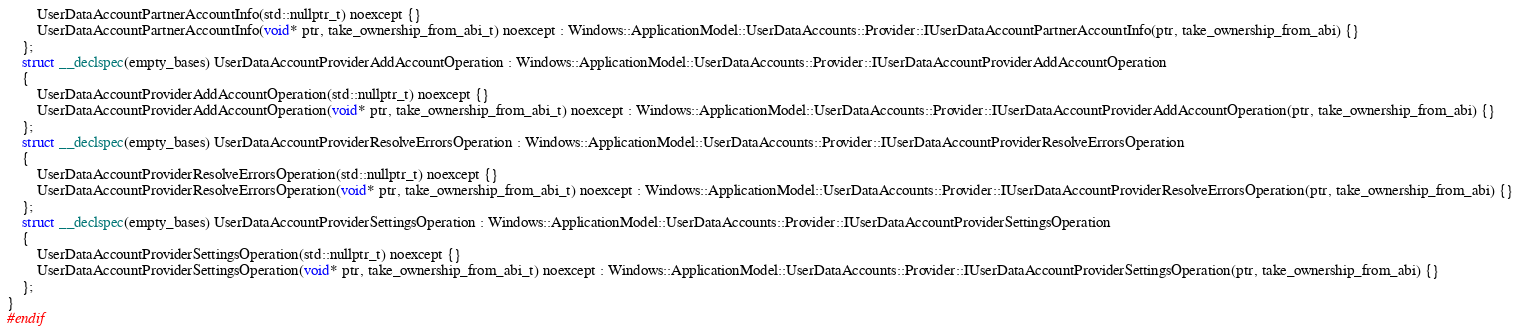<code> <loc_0><loc_0><loc_500><loc_500><_C_>        UserDataAccountPartnerAccountInfo(std::nullptr_t) noexcept {}
        UserDataAccountPartnerAccountInfo(void* ptr, take_ownership_from_abi_t) noexcept : Windows::ApplicationModel::UserDataAccounts::Provider::IUserDataAccountPartnerAccountInfo(ptr, take_ownership_from_abi) {}
    };
    struct __declspec(empty_bases) UserDataAccountProviderAddAccountOperation : Windows::ApplicationModel::UserDataAccounts::Provider::IUserDataAccountProviderAddAccountOperation
    {
        UserDataAccountProviderAddAccountOperation(std::nullptr_t) noexcept {}
        UserDataAccountProviderAddAccountOperation(void* ptr, take_ownership_from_abi_t) noexcept : Windows::ApplicationModel::UserDataAccounts::Provider::IUserDataAccountProviderAddAccountOperation(ptr, take_ownership_from_abi) {}
    };
    struct __declspec(empty_bases) UserDataAccountProviderResolveErrorsOperation : Windows::ApplicationModel::UserDataAccounts::Provider::IUserDataAccountProviderResolveErrorsOperation
    {
        UserDataAccountProviderResolveErrorsOperation(std::nullptr_t) noexcept {}
        UserDataAccountProviderResolveErrorsOperation(void* ptr, take_ownership_from_abi_t) noexcept : Windows::ApplicationModel::UserDataAccounts::Provider::IUserDataAccountProviderResolveErrorsOperation(ptr, take_ownership_from_abi) {}
    };
    struct __declspec(empty_bases) UserDataAccountProviderSettingsOperation : Windows::ApplicationModel::UserDataAccounts::Provider::IUserDataAccountProviderSettingsOperation
    {
        UserDataAccountProviderSettingsOperation(std::nullptr_t) noexcept {}
        UserDataAccountProviderSettingsOperation(void* ptr, take_ownership_from_abi_t) noexcept : Windows::ApplicationModel::UserDataAccounts::Provider::IUserDataAccountProviderSettingsOperation(ptr, take_ownership_from_abi) {}
    };
}
#endif
</code> 